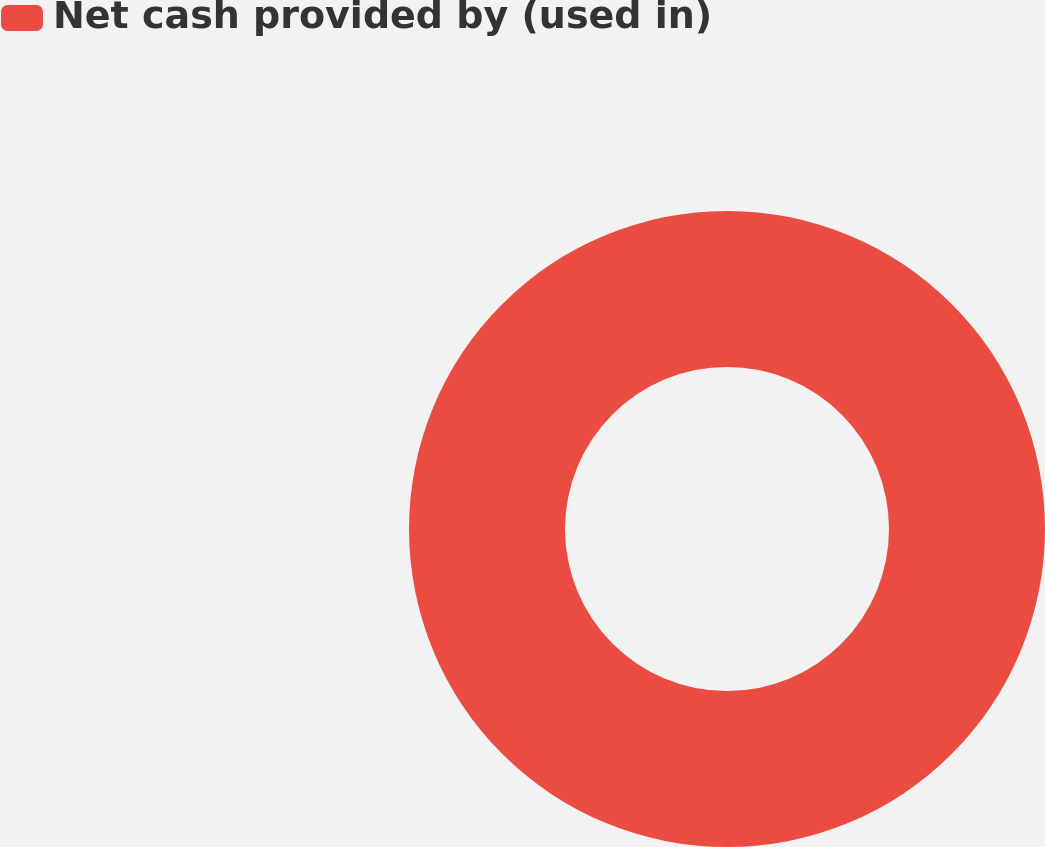Convert chart. <chart><loc_0><loc_0><loc_500><loc_500><pie_chart><fcel>Net cash provided by (used in)<nl><fcel>100.0%<nl></chart> 